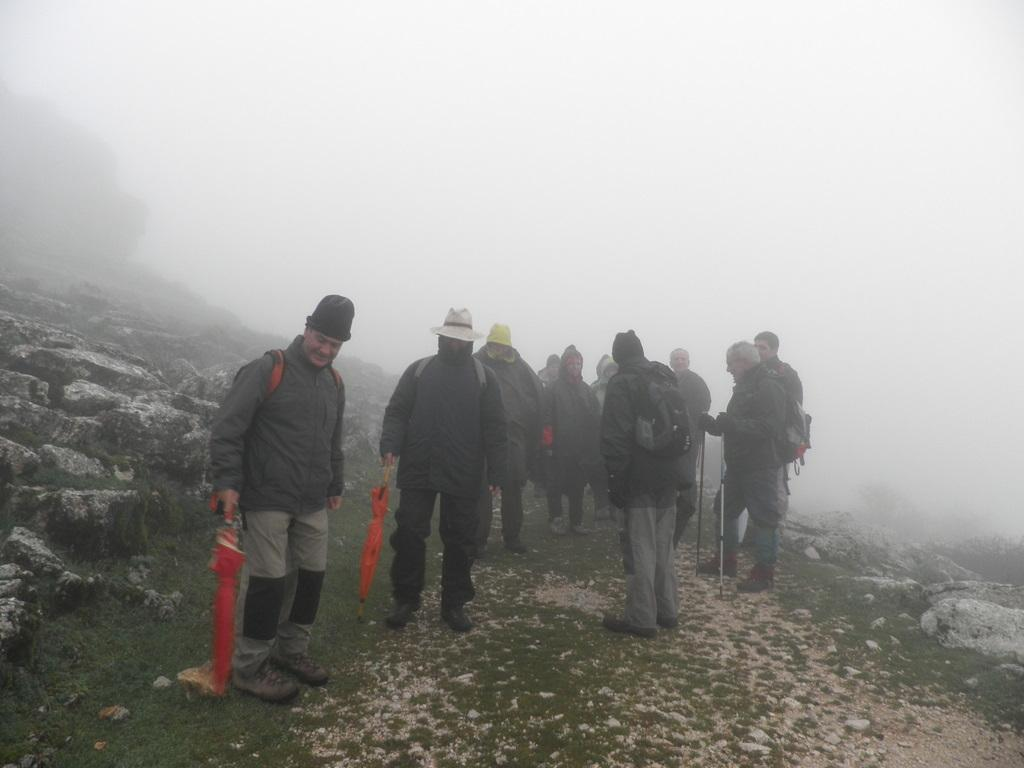What is the main subject of the image? The main subject of the image is people standing in the center. What type of surface are the people standing on? There is grass visible at the bottom of the image, so the people are likely standing on grass. Is the grass in the image actually quicksand? No, the grass in the image is not quicksand; it is a solid surface for the people to stand on. 